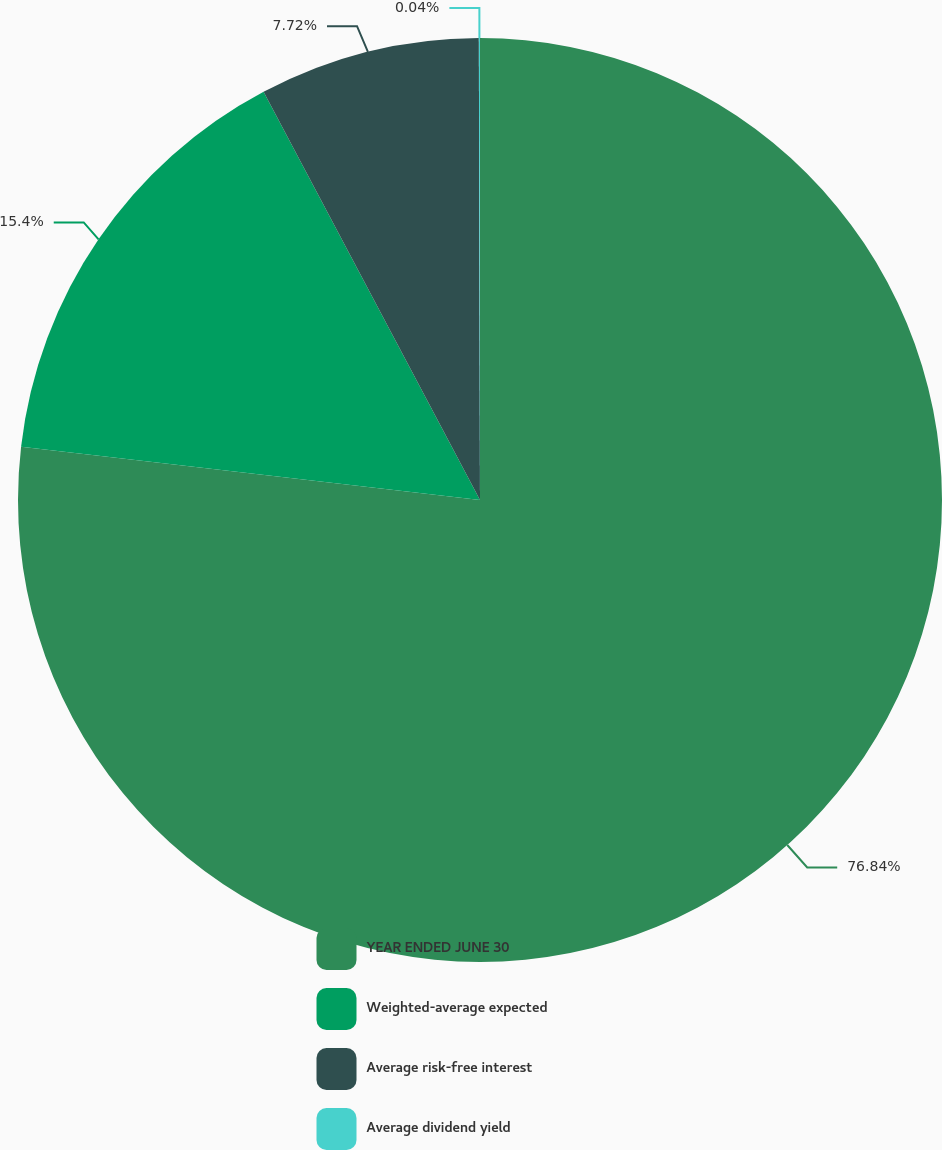Convert chart. <chart><loc_0><loc_0><loc_500><loc_500><pie_chart><fcel>YEAR ENDED JUNE 30<fcel>Weighted-average expected<fcel>Average risk-free interest<fcel>Average dividend yield<nl><fcel>76.84%<fcel>15.4%<fcel>7.72%<fcel>0.04%<nl></chart> 